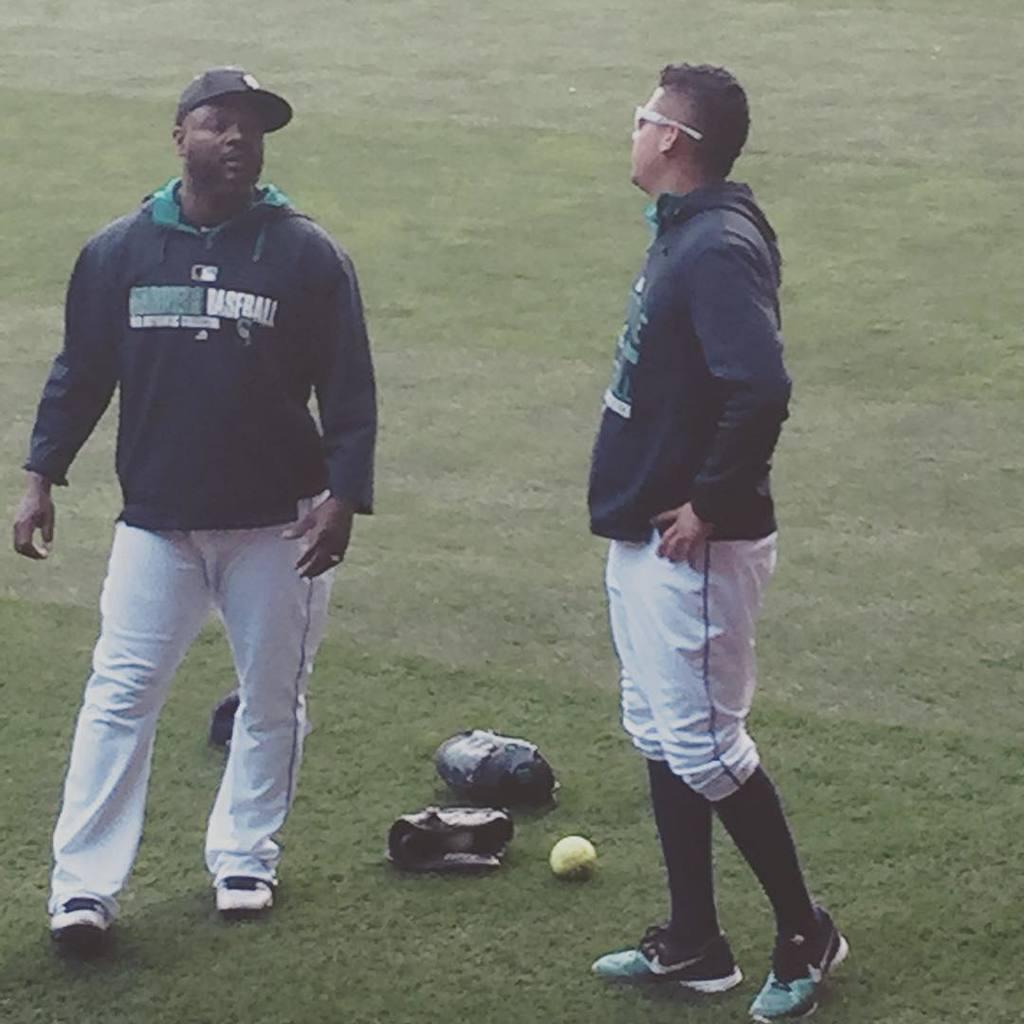What sport is represented on the hoodie?
Offer a terse response. Baseball. 